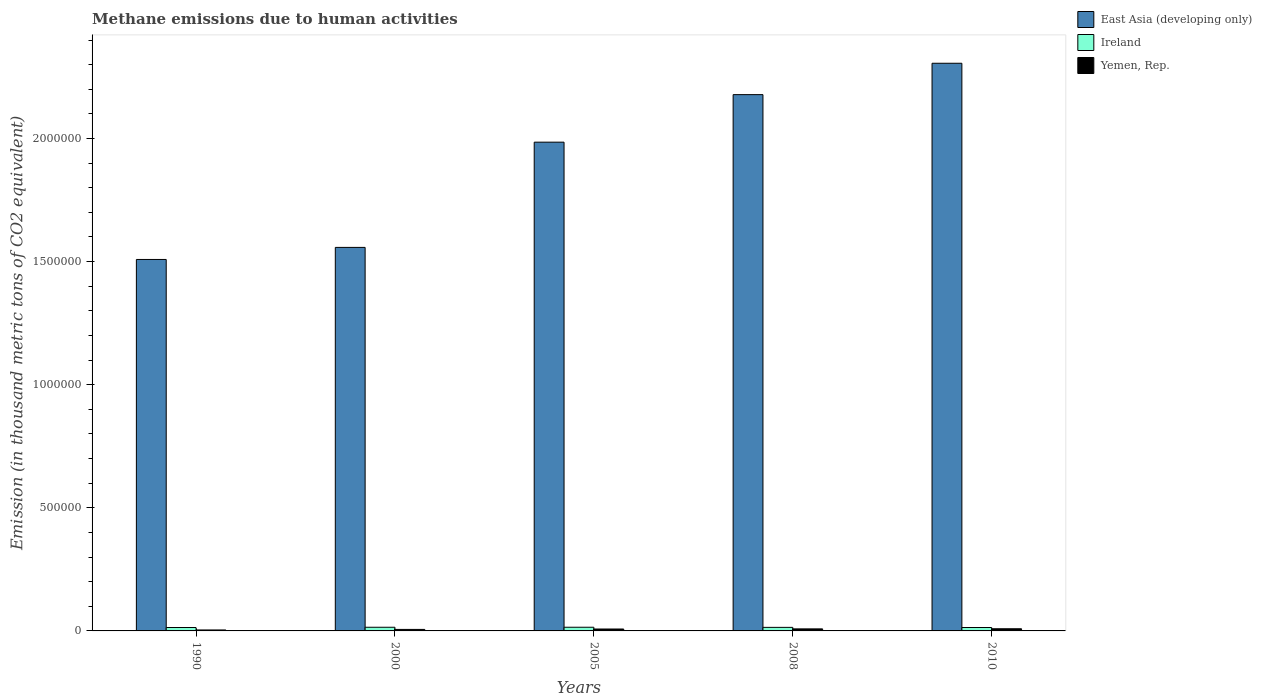How many different coloured bars are there?
Offer a very short reply. 3. How many groups of bars are there?
Provide a succinct answer. 5. Are the number of bars on each tick of the X-axis equal?
Provide a succinct answer. Yes. What is the label of the 5th group of bars from the left?
Make the answer very short. 2010. What is the amount of methane emitted in East Asia (developing only) in 1990?
Provide a succinct answer. 1.51e+06. Across all years, what is the maximum amount of methane emitted in Ireland?
Ensure brevity in your answer.  1.50e+04. Across all years, what is the minimum amount of methane emitted in East Asia (developing only)?
Give a very brief answer. 1.51e+06. In which year was the amount of methane emitted in Ireland maximum?
Give a very brief answer. 2005. What is the total amount of methane emitted in East Asia (developing only) in the graph?
Your response must be concise. 9.54e+06. What is the difference between the amount of methane emitted in Ireland in 2000 and that in 2005?
Offer a very short reply. -63.1. What is the difference between the amount of methane emitted in East Asia (developing only) in 2000 and the amount of methane emitted in Yemen, Rep. in 2010?
Your answer should be very brief. 1.55e+06. What is the average amount of methane emitted in East Asia (developing only) per year?
Offer a terse response. 1.91e+06. In the year 1990, what is the difference between the amount of methane emitted in East Asia (developing only) and amount of methane emitted in Ireland?
Keep it short and to the point. 1.49e+06. What is the ratio of the amount of methane emitted in Yemen, Rep. in 2000 to that in 2010?
Offer a very short reply. 0.7. Is the amount of methane emitted in Yemen, Rep. in 2005 less than that in 2010?
Provide a short and direct response. Yes. What is the difference between the highest and the second highest amount of methane emitted in Yemen, Rep.?
Your response must be concise. 472.3. What is the difference between the highest and the lowest amount of methane emitted in Ireland?
Make the answer very short. 1076.2. What does the 2nd bar from the left in 1990 represents?
Keep it short and to the point. Ireland. What does the 1st bar from the right in 2000 represents?
Provide a succinct answer. Yemen, Rep. Is it the case that in every year, the sum of the amount of methane emitted in Ireland and amount of methane emitted in East Asia (developing only) is greater than the amount of methane emitted in Yemen, Rep.?
Offer a very short reply. Yes. How many bars are there?
Your answer should be very brief. 15. Are all the bars in the graph horizontal?
Provide a succinct answer. No. How many years are there in the graph?
Your answer should be compact. 5. What is the difference between two consecutive major ticks on the Y-axis?
Keep it short and to the point. 5.00e+05. How are the legend labels stacked?
Give a very brief answer. Vertical. What is the title of the graph?
Ensure brevity in your answer.  Methane emissions due to human activities. Does "Sao Tome and Principe" appear as one of the legend labels in the graph?
Provide a succinct answer. No. What is the label or title of the X-axis?
Make the answer very short. Years. What is the label or title of the Y-axis?
Provide a succinct answer. Emission (in thousand metric tons of CO2 equivalent). What is the Emission (in thousand metric tons of CO2 equivalent) in East Asia (developing only) in 1990?
Your response must be concise. 1.51e+06. What is the Emission (in thousand metric tons of CO2 equivalent) of Ireland in 1990?
Provide a short and direct response. 1.39e+04. What is the Emission (in thousand metric tons of CO2 equivalent) in Yemen, Rep. in 1990?
Your answer should be very brief. 3912.6. What is the Emission (in thousand metric tons of CO2 equivalent) of East Asia (developing only) in 2000?
Ensure brevity in your answer.  1.56e+06. What is the Emission (in thousand metric tons of CO2 equivalent) in Ireland in 2000?
Make the answer very short. 1.49e+04. What is the Emission (in thousand metric tons of CO2 equivalent) in Yemen, Rep. in 2000?
Ensure brevity in your answer.  6121.1. What is the Emission (in thousand metric tons of CO2 equivalent) of East Asia (developing only) in 2005?
Your answer should be compact. 1.99e+06. What is the Emission (in thousand metric tons of CO2 equivalent) of Ireland in 2005?
Make the answer very short. 1.50e+04. What is the Emission (in thousand metric tons of CO2 equivalent) in Yemen, Rep. in 2005?
Make the answer very short. 7761.1. What is the Emission (in thousand metric tons of CO2 equivalent) in East Asia (developing only) in 2008?
Provide a short and direct response. 2.18e+06. What is the Emission (in thousand metric tons of CO2 equivalent) of Ireland in 2008?
Ensure brevity in your answer.  1.44e+04. What is the Emission (in thousand metric tons of CO2 equivalent) of Yemen, Rep. in 2008?
Your answer should be compact. 8292.4. What is the Emission (in thousand metric tons of CO2 equivalent) of East Asia (developing only) in 2010?
Offer a very short reply. 2.31e+06. What is the Emission (in thousand metric tons of CO2 equivalent) of Ireland in 2010?
Offer a terse response. 1.39e+04. What is the Emission (in thousand metric tons of CO2 equivalent) in Yemen, Rep. in 2010?
Provide a short and direct response. 8764.7. Across all years, what is the maximum Emission (in thousand metric tons of CO2 equivalent) in East Asia (developing only)?
Provide a succinct answer. 2.31e+06. Across all years, what is the maximum Emission (in thousand metric tons of CO2 equivalent) in Ireland?
Provide a short and direct response. 1.50e+04. Across all years, what is the maximum Emission (in thousand metric tons of CO2 equivalent) in Yemen, Rep.?
Your response must be concise. 8764.7. Across all years, what is the minimum Emission (in thousand metric tons of CO2 equivalent) in East Asia (developing only)?
Your answer should be very brief. 1.51e+06. Across all years, what is the minimum Emission (in thousand metric tons of CO2 equivalent) in Ireland?
Provide a short and direct response. 1.39e+04. Across all years, what is the minimum Emission (in thousand metric tons of CO2 equivalent) of Yemen, Rep.?
Provide a short and direct response. 3912.6. What is the total Emission (in thousand metric tons of CO2 equivalent) in East Asia (developing only) in the graph?
Provide a succinct answer. 9.54e+06. What is the total Emission (in thousand metric tons of CO2 equivalent) of Ireland in the graph?
Your answer should be very brief. 7.21e+04. What is the total Emission (in thousand metric tons of CO2 equivalent) in Yemen, Rep. in the graph?
Your response must be concise. 3.49e+04. What is the difference between the Emission (in thousand metric tons of CO2 equivalent) in East Asia (developing only) in 1990 and that in 2000?
Offer a very short reply. -4.90e+04. What is the difference between the Emission (in thousand metric tons of CO2 equivalent) in Ireland in 1990 and that in 2000?
Your response must be concise. -1013.1. What is the difference between the Emission (in thousand metric tons of CO2 equivalent) in Yemen, Rep. in 1990 and that in 2000?
Offer a very short reply. -2208.5. What is the difference between the Emission (in thousand metric tons of CO2 equivalent) of East Asia (developing only) in 1990 and that in 2005?
Ensure brevity in your answer.  -4.76e+05. What is the difference between the Emission (in thousand metric tons of CO2 equivalent) of Ireland in 1990 and that in 2005?
Ensure brevity in your answer.  -1076.2. What is the difference between the Emission (in thousand metric tons of CO2 equivalent) of Yemen, Rep. in 1990 and that in 2005?
Make the answer very short. -3848.5. What is the difference between the Emission (in thousand metric tons of CO2 equivalent) of East Asia (developing only) in 1990 and that in 2008?
Offer a terse response. -6.69e+05. What is the difference between the Emission (in thousand metric tons of CO2 equivalent) of Ireland in 1990 and that in 2008?
Offer a terse response. -531.2. What is the difference between the Emission (in thousand metric tons of CO2 equivalent) in Yemen, Rep. in 1990 and that in 2008?
Keep it short and to the point. -4379.8. What is the difference between the Emission (in thousand metric tons of CO2 equivalent) in East Asia (developing only) in 1990 and that in 2010?
Your answer should be very brief. -7.97e+05. What is the difference between the Emission (in thousand metric tons of CO2 equivalent) of Ireland in 1990 and that in 2010?
Provide a short and direct response. -11.6. What is the difference between the Emission (in thousand metric tons of CO2 equivalent) of Yemen, Rep. in 1990 and that in 2010?
Offer a very short reply. -4852.1. What is the difference between the Emission (in thousand metric tons of CO2 equivalent) of East Asia (developing only) in 2000 and that in 2005?
Provide a short and direct response. -4.27e+05. What is the difference between the Emission (in thousand metric tons of CO2 equivalent) of Ireland in 2000 and that in 2005?
Offer a very short reply. -63.1. What is the difference between the Emission (in thousand metric tons of CO2 equivalent) of Yemen, Rep. in 2000 and that in 2005?
Keep it short and to the point. -1640. What is the difference between the Emission (in thousand metric tons of CO2 equivalent) of East Asia (developing only) in 2000 and that in 2008?
Your answer should be very brief. -6.20e+05. What is the difference between the Emission (in thousand metric tons of CO2 equivalent) in Ireland in 2000 and that in 2008?
Give a very brief answer. 481.9. What is the difference between the Emission (in thousand metric tons of CO2 equivalent) of Yemen, Rep. in 2000 and that in 2008?
Make the answer very short. -2171.3. What is the difference between the Emission (in thousand metric tons of CO2 equivalent) in East Asia (developing only) in 2000 and that in 2010?
Give a very brief answer. -7.48e+05. What is the difference between the Emission (in thousand metric tons of CO2 equivalent) of Ireland in 2000 and that in 2010?
Your response must be concise. 1001.5. What is the difference between the Emission (in thousand metric tons of CO2 equivalent) of Yemen, Rep. in 2000 and that in 2010?
Provide a short and direct response. -2643.6. What is the difference between the Emission (in thousand metric tons of CO2 equivalent) of East Asia (developing only) in 2005 and that in 2008?
Keep it short and to the point. -1.93e+05. What is the difference between the Emission (in thousand metric tons of CO2 equivalent) of Ireland in 2005 and that in 2008?
Provide a short and direct response. 545. What is the difference between the Emission (in thousand metric tons of CO2 equivalent) in Yemen, Rep. in 2005 and that in 2008?
Your answer should be compact. -531.3. What is the difference between the Emission (in thousand metric tons of CO2 equivalent) of East Asia (developing only) in 2005 and that in 2010?
Your answer should be compact. -3.20e+05. What is the difference between the Emission (in thousand metric tons of CO2 equivalent) in Ireland in 2005 and that in 2010?
Provide a short and direct response. 1064.6. What is the difference between the Emission (in thousand metric tons of CO2 equivalent) of Yemen, Rep. in 2005 and that in 2010?
Your answer should be compact. -1003.6. What is the difference between the Emission (in thousand metric tons of CO2 equivalent) in East Asia (developing only) in 2008 and that in 2010?
Give a very brief answer. -1.27e+05. What is the difference between the Emission (in thousand metric tons of CO2 equivalent) in Ireland in 2008 and that in 2010?
Give a very brief answer. 519.6. What is the difference between the Emission (in thousand metric tons of CO2 equivalent) of Yemen, Rep. in 2008 and that in 2010?
Your answer should be very brief. -472.3. What is the difference between the Emission (in thousand metric tons of CO2 equivalent) in East Asia (developing only) in 1990 and the Emission (in thousand metric tons of CO2 equivalent) in Ireland in 2000?
Your response must be concise. 1.49e+06. What is the difference between the Emission (in thousand metric tons of CO2 equivalent) in East Asia (developing only) in 1990 and the Emission (in thousand metric tons of CO2 equivalent) in Yemen, Rep. in 2000?
Provide a succinct answer. 1.50e+06. What is the difference between the Emission (in thousand metric tons of CO2 equivalent) of Ireland in 1990 and the Emission (in thousand metric tons of CO2 equivalent) of Yemen, Rep. in 2000?
Provide a short and direct response. 7762.8. What is the difference between the Emission (in thousand metric tons of CO2 equivalent) of East Asia (developing only) in 1990 and the Emission (in thousand metric tons of CO2 equivalent) of Ireland in 2005?
Offer a terse response. 1.49e+06. What is the difference between the Emission (in thousand metric tons of CO2 equivalent) of East Asia (developing only) in 1990 and the Emission (in thousand metric tons of CO2 equivalent) of Yemen, Rep. in 2005?
Keep it short and to the point. 1.50e+06. What is the difference between the Emission (in thousand metric tons of CO2 equivalent) in Ireland in 1990 and the Emission (in thousand metric tons of CO2 equivalent) in Yemen, Rep. in 2005?
Your answer should be compact. 6122.8. What is the difference between the Emission (in thousand metric tons of CO2 equivalent) in East Asia (developing only) in 1990 and the Emission (in thousand metric tons of CO2 equivalent) in Ireland in 2008?
Your answer should be compact. 1.49e+06. What is the difference between the Emission (in thousand metric tons of CO2 equivalent) in East Asia (developing only) in 1990 and the Emission (in thousand metric tons of CO2 equivalent) in Yemen, Rep. in 2008?
Keep it short and to the point. 1.50e+06. What is the difference between the Emission (in thousand metric tons of CO2 equivalent) in Ireland in 1990 and the Emission (in thousand metric tons of CO2 equivalent) in Yemen, Rep. in 2008?
Make the answer very short. 5591.5. What is the difference between the Emission (in thousand metric tons of CO2 equivalent) of East Asia (developing only) in 1990 and the Emission (in thousand metric tons of CO2 equivalent) of Ireland in 2010?
Offer a terse response. 1.49e+06. What is the difference between the Emission (in thousand metric tons of CO2 equivalent) of East Asia (developing only) in 1990 and the Emission (in thousand metric tons of CO2 equivalent) of Yemen, Rep. in 2010?
Keep it short and to the point. 1.50e+06. What is the difference between the Emission (in thousand metric tons of CO2 equivalent) in Ireland in 1990 and the Emission (in thousand metric tons of CO2 equivalent) in Yemen, Rep. in 2010?
Provide a short and direct response. 5119.2. What is the difference between the Emission (in thousand metric tons of CO2 equivalent) in East Asia (developing only) in 2000 and the Emission (in thousand metric tons of CO2 equivalent) in Ireland in 2005?
Offer a very short reply. 1.54e+06. What is the difference between the Emission (in thousand metric tons of CO2 equivalent) in East Asia (developing only) in 2000 and the Emission (in thousand metric tons of CO2 equivalent) in Yemen, Rep. in 2005?
Your answer should be very brief. 1.55e+06. What is the difference between the Emission (in thousand metric tons of CO2 equivalent) of Ireland in 2000 and the Emission (in thousand metric tons of CO2 equivalent) of Yemen, Rep. in 2005?
Provide a succinct answer. 7135.9. What is the difference between the Emission (in thousand metric tons of CO2 equivalent) of East Asia (developing only) in 2000 and the Emission (in thousand metric tons of CO2 equivalent) of Ireland in 2008?
Provide a succinct answer. 1.54e+06. What is the difference between the Emission (in thousand metric tons of CO2 equivalent) of East Asia (developing only) in 2000 and the Emission (in thousand metric tons of CO2 equivalent) of Yemen, Rep. in 2008?
Your response must be concise. 1.55e+06. What is the difference between the Emission (in thousand metric tons of CO2 equivalent) in Ireland in 2000 and the Emission (in thousand metric tons of CO2 equivalent) in Yemen, Rep. in 2008?
Offer a terse response. 6604.6. What is the difference between the Emission (in thousand metric tons of CO2 equivalent) of East Asia (developing only) in 2000 and the Emission (in thousand metric tons of CO2 equivalent) of Ireland in 2010?
Ensure brevity in your answer.  1.54e+06. What is the difference between the Emission (in thousand metric tons of CO2 equivalent) in East Asia (developing only) in 2000 and the Emission (in thousand metric tons of CO2 equivalent) in Yemen, Rep. in 2010?
Offer a terse response. 1.55e+06. What is the difference between the Emission (in thousand metric tons of CO2 equivalent) in Ireland in 2000 and the Emission (in thousand metric tons of CO2 equivalent) in Yemen, Rep. in 2010?
Ensure brevity in your answer.  6132.3. What is the difference between the Emission (in thousand metric tons of CO2 equivalent) of East Asia (developing only) in 2005 and the Emission (in thousand metric tons of CO2 equivalent) of Ireland in 2008?
Your response must be concise. 1.97e+06. What is the difference between the Emission (in thousand metric tons of CO2 equivalent) in East Asia (developing only) in 2005 and the Emission (in thousand metric tons of CO2 equivalent) in Yemen, Rep. in 2008?
Ensure brevity in your answer.  1.98e+06. What is the difference between the Emission (in thousand metric tons of CO2 equivalent) in Ireland in 2005 and the Emission (in thousand metric tons of CO2 equivalent) in Yemen, Rep. in 2008?
Your answer should be compact. 6667.7. What is the difference between the Emission (in thousand metric tons of CO2 equivalent) of East Asia (developing only) in 2005 and the Emission (in thousand metric tons of CO2 equivalent) of Ireland in 2010?
Your answer should be very brief. 1.97e+06. What is the difference between the Emission (in thousand metric tons of CO2 equivalent) of East Asia (developing only) in 2005 and the Emission (in thousand metric tons of CO2 equivalent) of Yemen, Rep. in 2010?
Your answer should be very brief. 1.98e+06. What is the difference between the Emission (in thousand metric tons of CO2 equivalent) of Ireland in 2005 and the Emission (in thousand metric tons of CO2 equivalent) of Yemen, Rep. in 2010?
Your response must be concise. 6195.4. What is the difference between the Emission (in thousand metric tons of CO2 equivalent) of East Asia (developing only) in 2008 and the Emission (in thousand metric tons of CO2 equivalent) of Ireland in 2010?
Provide a short and direct response. 2.16e+06. What is the difference between the Emission (in thousand metric tons of CO2 equivalent) in East Asia (developing only) in 2008 and the Emission (in thousand metric tons of CO2 equivalent) in Yemen, Rep. in 2010?
Offer a terse response. 2.17e+06. What is the difference between the Emission (in thousand metric tons of CO2 equivalent) in Ireland in 2008 and the Emission (in thousand metric tons of CO2 equivalent) in Yemen, Rep. in 2010?
Offer a very short reply. 5650.4. What is the average Emission (in thousand metric tons of CO2 equivalent) in East Asia (developing only) per year?
Your answer should be very brief. 1.91e+06. What is the average Emission (in thousand metric tons of CO2 equivalent) of Ireland per year?
Your answer should be very brief. 1.44e+04. What is the average Emission (in thousand metric tons of CO2 equivalent) in Yemen, Rep. per year?
Offer a very short reply. 6970.38. In the year 1990, what is the difference between the Emission (in thousand metric tons of CO2 equivalent) of East Asia (developing only) and Emission (in thousand metric tons of CO2 equivalent) of Ireland?
Provide a short and direct response. 1.49e+06. In the year 1990, what is the difference between the Emission (in thousand metric tons of CO2 equivalent) in East Asia (developing only) and Emission (in thousand metric tons of CO2 equivalent) in Yemen, Rep.?
Offer a very short reply. 1.50e+06. In the year 1990, what is the difference between the Emission (in thousand metric tons of CO2 equivalent) of Ireland and Emission (in thousand metric tons of CO2 equivalent) of Yemen, Rep.?
Your answer should be compact. 9971.3. In the year 2000, what is the difference between the Emission (in thousand metric tons of CO2 equivalent) of East Asia (developing only) and Emission (in thousand metric tons of CO2 equivalent) of Ireland?
Make the answer very short. 1.54e+06. In the year 2000, what is the difference between the Emission (in thousand metric tons of CO2 equivalent) of East Asia (developing only) and Emission (in thousand metric tons of CO2 equivalent) of Yemen, Rep.?
Keep it short and to the point. 1.55e+06. In the year 2000, what is the difference between the Emission (in thousand metric tons of CO2 equivalent) in Ireland and Emission (in thousand metric tons of CO2 equivalent) in Yemen, Rep.?
Give a very brief answer. 8775.9. In the year 2005, what is the difference between the Emission (in thousand metric tons of CO2 equivalent) in East Asia (developing only) and Emission (in thousand metric tons of CO2 equivalent) in Ireland?
Your answer should be compact. 1.97e+06. In the year 2005, what is the difference between the Emission (in thousand metric tons of CO2 equivalent) in East Asia (developing only) and Emission (in thousand metric tons of CO2 equivalent) in Yemen, Rep.?
Offer a terse response. 1.98e+06. In the year 2005, what is the difference between the Emission (in thousand metric tons of CO2 equivalent) of Ireland and Emission (in thousand metric tons of CO2 equivalent) of Yemen, Rep.?
Offer a terse response. 7199. In the year 2008, what is the difference between the Emission (in thousand metric tons of CO2 equivalent) in East Asia (developing only) and Emission (in thousand metric tons of CO2 equivalent) in Ireland?
Make the answer very short. 2.16e+06. In the year 2008, what is the difference between the Emission (in thousand metric tons of CO2 equivalent) in East Asia (developing only) and Emission (in thousand metric tons of CO2 equivalent) in Yemen, Rep.?
Offer a terse response. 2.17e+06. In the year 2008, what is the difference between the Emission (in thousand metric tons of CO2 equivalent) of Ireland and Emission (in thousand metric tons of CO2 equivalent) of Yemen, Rep.?
Ensure brevity in your answer.  6122.7. In the year 2010, what is the difference between the Emission (in thousand metric tons of CO2 equivalent) in East Asia (developing only) and Emission (in thousand metric tons of CO2 equivalent) in Ireland?
Your answer should be very brief. 2.29e+06. In the year 2010, what is the difference between the Emission (in thousand metric tons of CO2 equivalent) in East Asia (developing only) and Emission (in thousand metric tons of CO2 equivalent) in Yemen, Rep.?
Provide a succinct answer. 2.30e+06. In the year 2010, what is the difference between the Emission (in thousand metric tons of CO2 equivalent) of Ireland and Emission (in thousand metric tons of CO2 equivalent) of Yemen, Rep.?
Offer a terse response. 5130.8. What is the ratio of the Emission (in thousand metric tons of CO2 equivalent) of East Asia (developing only) in 1990 to that in 2000?
Provide a succinct answer. 0.97. What is the ratio of the Emission (in thousand metric tons of CO2 equivalent) of Ireland in 1990 to that in 2000?
Your answer should be compact. 0.93. What is the ratio of the Emission (in thousand metric tons of CO2 equivalent) in Yemen, Rep. in 1990 to that in 2000?
Ensure brevity in your answer.  0.64. What is the ratio of the Emission (in thousand metric tons of CO2 equivalent) in East Asia (developing only) in 1990 to that in 2005?
Offer a terse response. 0.76. What is the ratio of the Emission (in thousand metric tons of CO2 equivalent) of Ireland in 1990 to that in 2005?
Your answer should be compact. 0.93. What is the ratio of the Emission (in thousand metric tons of CO2 equivalent) of Yemen, Rep. in 1990 to that in 2005?
Your answer should be compact. 0.5. What is the ratio of the Emission (in thousand metric tons of CO2 equivalent) of East Asia (developing only) in 1990 to that in 2008?
Make the answer very short. 0.69. What is the ratio of the Emission (in thousand metric tons of CO2 equivalent) of Ireland in 1990 to that in 2008?
Provide a short and direct response. 0.96. What is the ratio of the Emission (in thousand metric tons of CO2 equivalent) in Yemen, Rep. in 1990 to that in 2008?
Your answer should be compact. 0.47. What is the ratio of the Emission (in thousand metric tons of CO2 equivalent) of East Asia (developing only) in 1990 to that in 2010?
Give a very brief answer. 0.65. What is the ratio of the Emission (in thousand metric tons of CO2 equivalent) of Ireland in 1990 to that in 2010?
Offer a terse response. 1. What is the ratio of the Emission (in thousand metric tons of CO2 equivalent) of Yemen, Rep. in 1990 to that in 2010?
Your answer should be compact. 0.45. What is the ratio of the Emission (in thousand metric tons of CO2 equivalent) in East Asia (developing only) in 2000 to that in 2005?
Provide a short and direct response. 0.78. What is the ratio of the Emission (in thousand metric tons of CO2 equivalent) in Ireland in 2000 to that in 2005?
Make the answer very short. 1. What is the ratio of the Emission (in thousand metric tons of CO2 equivalent) in Yemen, Rep. in 2000 to that in 2005?
Make the answer very short. 0.79. What is the ratio of the Emission (in thousand metric tons of CO2 equivalent) of East Asia (developing only) in 2000 to that in 2008?
Your answer should be very brief. 0.72. What is the ratio of the Emission (in thousand metric tons of CO2 equivalent) in Ireland in 2000 to that in 2008?
Offer a terse response. 1.03. What is the ratio of the Emission (in thousand metric tons of CO2 equivalent) in Yemen, Rep. in 2000 to that in 2008?
Keep it short and to the point. 0.74. What is the ratio of the Emission (in thousand metric tons of CO2 equivalent) of East Asia (developing only) in 2000 to that in 2010?
Provide a succinct answer. 0.68. What is the ratio of the Emission (in thousand metric tons of CO2 equivalent) of Ireland in 2000 to that in 2010?
Make the answer very short. 1.07. What is the ratio of the Emission (in thousand metric tons of CO2 equivalent) in Yemen, Rep. in 2000 to that in 2010?
Provide a short and direct response. 0.7. What is the ratio of the Emission (in thousand metric tons of CO2 equivalent) of East Asia (developing only) in 2005 to that in 2008?
Keep it short and to the point. 0.91. What is the ratio of the Emission (in thousand metric tons of CO2 equivalent) in Ireland in 2005 to that in 2008?
Provide a short and direct response. 1.04. What is the ratio of the Emission (in thousand metric tons of CO2 equivalent) in Yemen, Rep. in 2005 to that in 2008?
Your answer should be very brief. 0.94. What is the ratio of the Emission (in thousand metric tons of CO2 equivalent) of East Asia (developing only) in 2005 to that in 2010?
Offer a very short reply. 0.86. What is the ratio of the Emission (in thousand metric tons of CO2 equivalent) in Ireland in 2005 to that in 2010?
Provide a succinct answer. 1.08. What is the ratio of the Emission (in thousand metric tons of CO2 equivalent) in Yemen, Rep. in 2005 to that in 2010?
Provide a succinct answer. 0.89. What is the ratio of the Emission (in thousand metric tons of CO2 equivalent) in East Asia (developing only) in 2008 to that in 2010?
Provide a succinct answer. 0.94. What is the ratio of the Emission (in thousand metric tons of CO2 equivalent) in Ireland in 2008 to that in 2010?
Ensure brevity in your answer.  1.04. What is the ratio of the Emission (in thousand metric tons of CO2 equivalent) of Yemen, Rep. in 2008 to that in 2010?
Your response must be concise. 0.95. What is the difference between the highest and the second highest Emission (in thousand metric tons of CO2 equivalent) of East Asia (developing only)?
Offer a very short reply. 1.27e+05. What is the difference between the highest and the second highest Emission (in thousand metric tons of CO2 equivalent) of Ireland?
Your answer should be very brief. 63.1. What is the difference between the highest and the second highest Emission (in thousand metric tons of CO2 equivalent) of Yemen, Rep.?
Your response must be concise. 472.3. What is the difference between the highest and the lowest Emission (in thousand metric tons of CO2 equivalent) of East Asia (developing only)?
Offer a very short reply. 7.97e+05. What is the difference between the highest and the lowest Emission (in thousand metric tons of CO2 equivalent) of Ireland?
Your answer should be very brief. 1076.2. What is the difference between the highest and the lowest Emission (in thousand metric tons of CO2 equivalent) of Yemen, Rep.?
Ensure brevity in your answer.  4852.1. 